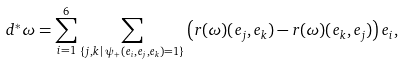Convert formula to latex. <formula><loc_0><loc_0><loc_500><loc_500>d ^ { * } \omega = \sum _ { i = 1 } ^ { 6 } \sum _ { \{ j , k \, | \, \psi _ { + } ( e _ { i } , e _ { j } , e _ { k } ) = 1 \} } \left ( r ( \omega ) ( e _ { j } , e _ { k } ) - r ( \omega ) ( e _ { k } , e _ { j } ) \right ) e _ { i } ,</formula> 